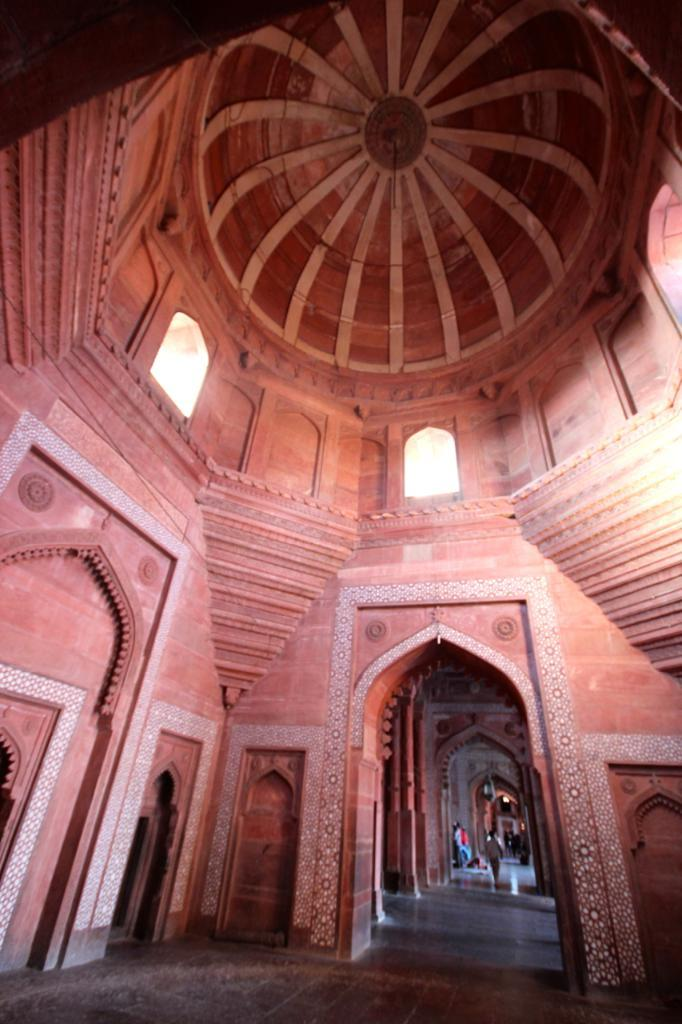What type of building is shown in the image? The image depicts an interior design of a monumental building. What are the people in the image doing? The people in the image are walking and standing in the building. Where are the people located within the building? The people are on the floor of the building. What type of soap can be seen in the image? There is no soap present in the image. Can you hear the snails moving in the image? There are no snails present in the image, so it is not possible to hear them moving. 